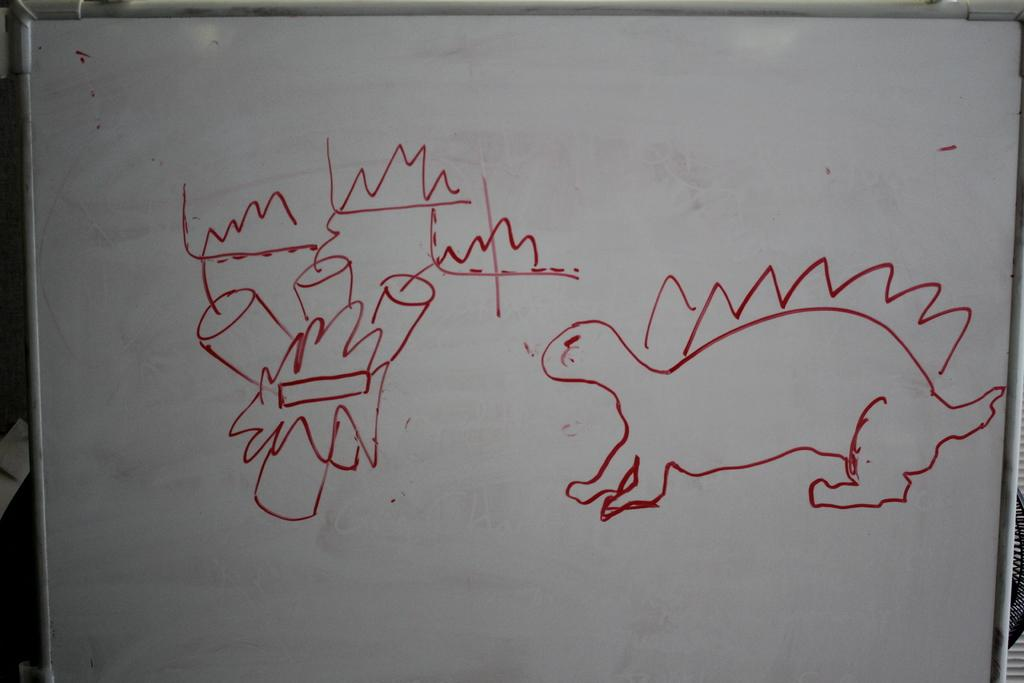What is on the board that is visible in the image? There is a board with drawings in the image. Can you describe the objects visible in the background of the image? Unfortunately, the provided facts do not give any specific details about the objects in the background. How many patches are on the dime in the image? There is no dime or patch present in the image. What is the date of birth of the person depicted in the image? There is no person depicted in the image, so it is impossible to determine their date of birth. 